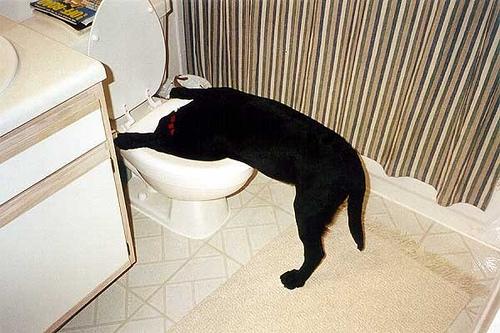What is the dog drinking from?
Keep it brief. Toilet. What animal is thirsty?
Be succinct. Dog. What color is the dog?
Answer briefly. Black. Is there a sink?
Give a very brief answer. Yes. 